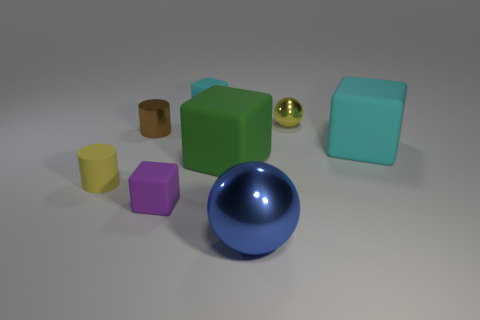Add 1 tiny yellow metallic blocks. How many objects exist? 9 Subtract all red blocks. Subtract all blue cylinders. How many blocks are left? 4 Subtract all cylinders. How many objects are left? 6 Subtract all big matte things. Subtract all big spheres. How many objects are left? 5 Add 4 big cyan matte objects. How many big cyan matte objects are left? 5 Add 7 brown metallic things. How many brown metallic things exist? 8 Subtract 0 gray blocks. How many objects are left? 8 